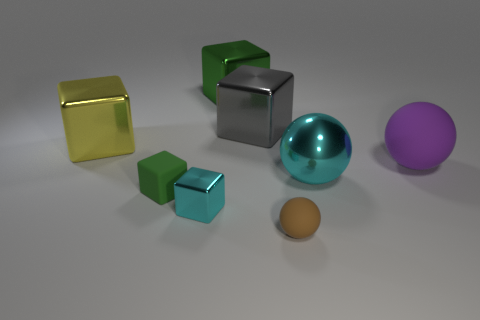There is another tiny metallic thing that is the same shape as the yellow thing; what color is it?
Your response must be concise. Cyan. Are there any other things of the same color as the small matte sphere?
Give a very brief answer. No. There is a cyan object that is behind the green cube in front of the shiny block to the left of the cyan metallic block; what is its shape?
Keep it short and to the point. Sphere. There is a shiny thing that is to the right of the tiny matte sphere; is it the same size as the green thing in front of the large yellow thing?
Your answer should be very brief. No. What number of big green blocks are made of the same material as the small cyan cube?
Your answer should be very brief. 1. What number of yellow things are behind the cyan object that is right of the cyan thing that is in front of the green matte block?
Ensure brevity in your answer.  1. Does the big gray thing have the same shape as the small green rubber thing?
Offer a very short reply. Yes. Is there another big metallic thing of the same shape as the large gray object?
Ensure brevity in your answer.  Yes. What shape is the rubber object that is the same size as the cyan sphere?
Offer a very short reply. Sphere. There is a block that is behind the large metallic cube that is to the right of the green block behind the big gray metal cube; what is its material?
Your response must be concise. Metal. 